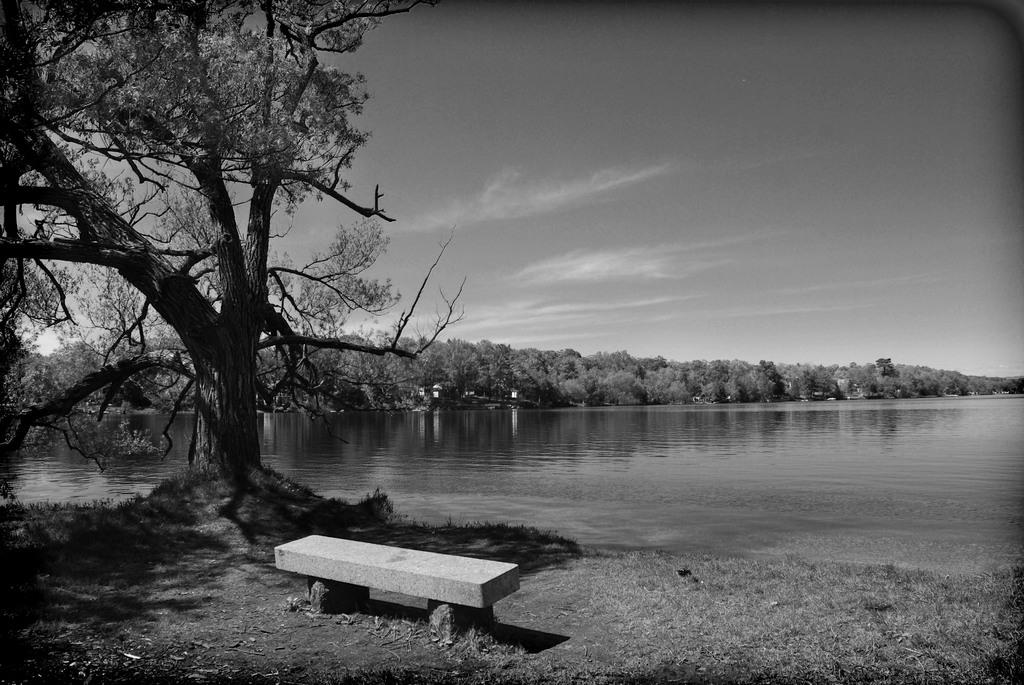What body of water is present in the image? There is a lake in the picture. What type of vegetation is near the lake? There are trees on the side of the lake. What type of seating is visible in the image? There is a marble bench at the bottom of the picture. What can be seen in the sky in the image? There are clouds in the sky. What type of mint is growing near the cake in the image? There is no mint or cake present in the image; it features a lake, trees, a marble bench, and clouds. 